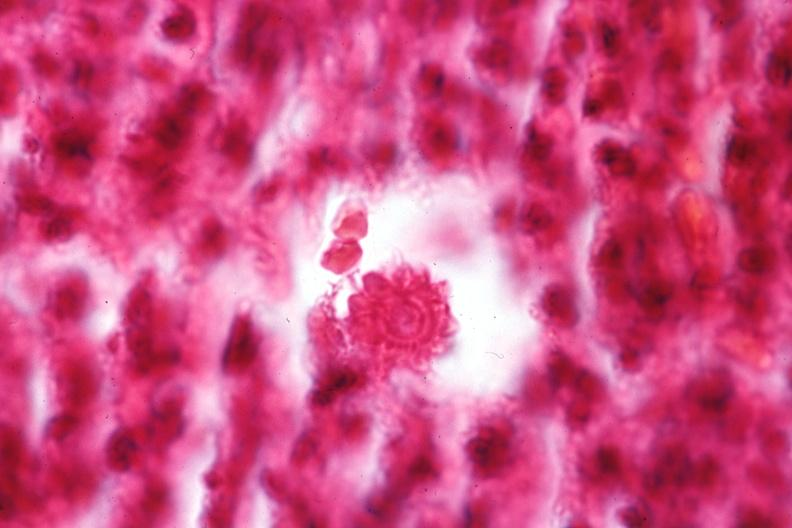does seminoma show oil immersion organism very well shown?
Answer the question using a single word or phrase. No 